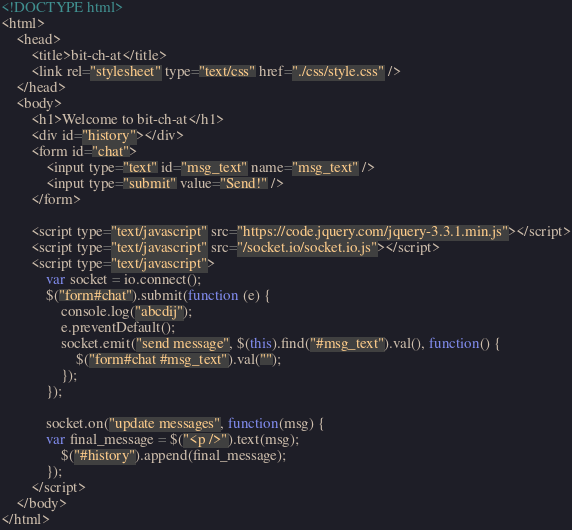Convert code to text. <code><loc_0><loc_0><loc_500><loc_500><_HTML_><!DOCTYPE html>
<html>
	<head>
		<title>bit-ch-at</title>
		<link rel="stylesheet" type="text/css" href="./css/style.css" />
	</head>
	<body>
		<h1>Welcome to bit-ch-at</h1>
		<div id="history"></div>
		<form id="chat">
			<input type="text" id="msg_text" name="msg_text" />
			<input type="submit" value="Send!" />
		</form>

		<script type="text/javascript" src="https://code.jquery.com/jquery-3.3.1.min.js"></script>
		<script type="text/javascript" src="/socket.io/socket.io.js"></script>
		<script type="text/javascript">
			var socket = io.connect();
			$("form#chat").submit(function (e) {
				console.log("abcdij");
				e.preventDefault();
				socket.emit("send message", $(this).find("#msg_text").val(), function() {
					$("form#chat #msg_text").val("");
				});
			});

			socket.on("update messages", function(msg) {
			var final_message = $("<p />").text(msg);
				$("#history").append(final_message);
			});
		</script>
	</body>
</html>
</code> 